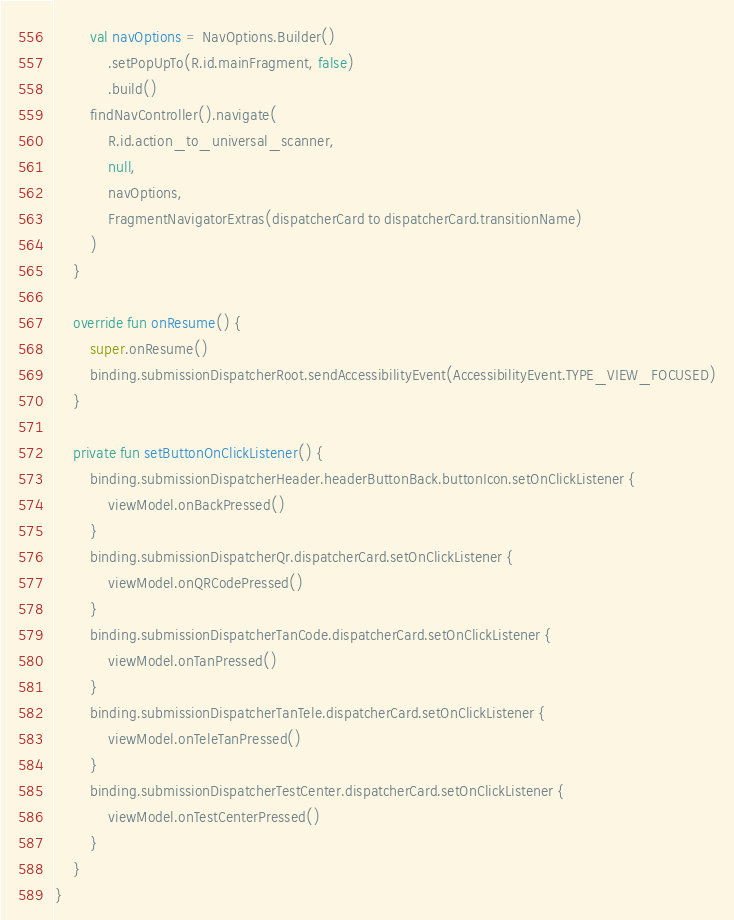<code> <loc_0><loc_0><loc_500><loc_500><_Kotlin_>        val navOptions = NavOptions.Builder()
            .setPopUpTo(R.id.mainFragment, false)
            .build()
        findNavController().navigate(
            R.id.action_to_universal_scanner,
            null,
            navOptions,
            FragmentNavigatorExtras(dispatcherCard to dispatcherCard.transitionName)
        )
    }

    override fun onResume() {
        super.onResume()
        binding.submissionDispatcherRoot.sendAccessibilityEvent(AccessibilityEvent.TYPE_VIEW_FOCUSED)
    }

    private fun setButtonOnClickListener() {
        binding.submissionDispatcherHeader.headerButtonBack.buttonIcon.setOnClickListener {
            viewModel.onBackPressed()
        }
        binding.submissionDispatcherQr.dispatcherCard.setOnClickListener {
            viewModel.onQRCodePressed()
        }
        binding.submissionDispatcherTanCode.dispatcherCard.setOnClickListener {
            viewModel.onTanPressed()
        }
        binding.submissionDispatcherTanTele.dispatcherCard.setOnClickListener {
            viewModel.onTeleTanPressed()
        }
        binding.submissionDispatcherTestCenter.dispatcherCard.setOnClickListener {
            viewModel.onTestCenterPressed()
        }
    }
}
</code> 